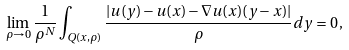Convert formula to latex. <formula><loc_0><loc_0><loc_500><loc_500>\lim _ { \rho \to 0 } \frac { 1 } { \rho ^ { N } } \int _ { Q ( x , \rho ) } \frac { | u ( y ) - u ( x ) - \nabla u ( x ) ( y - x ) | } { \rho } d y = 0 \, ,</formula> 